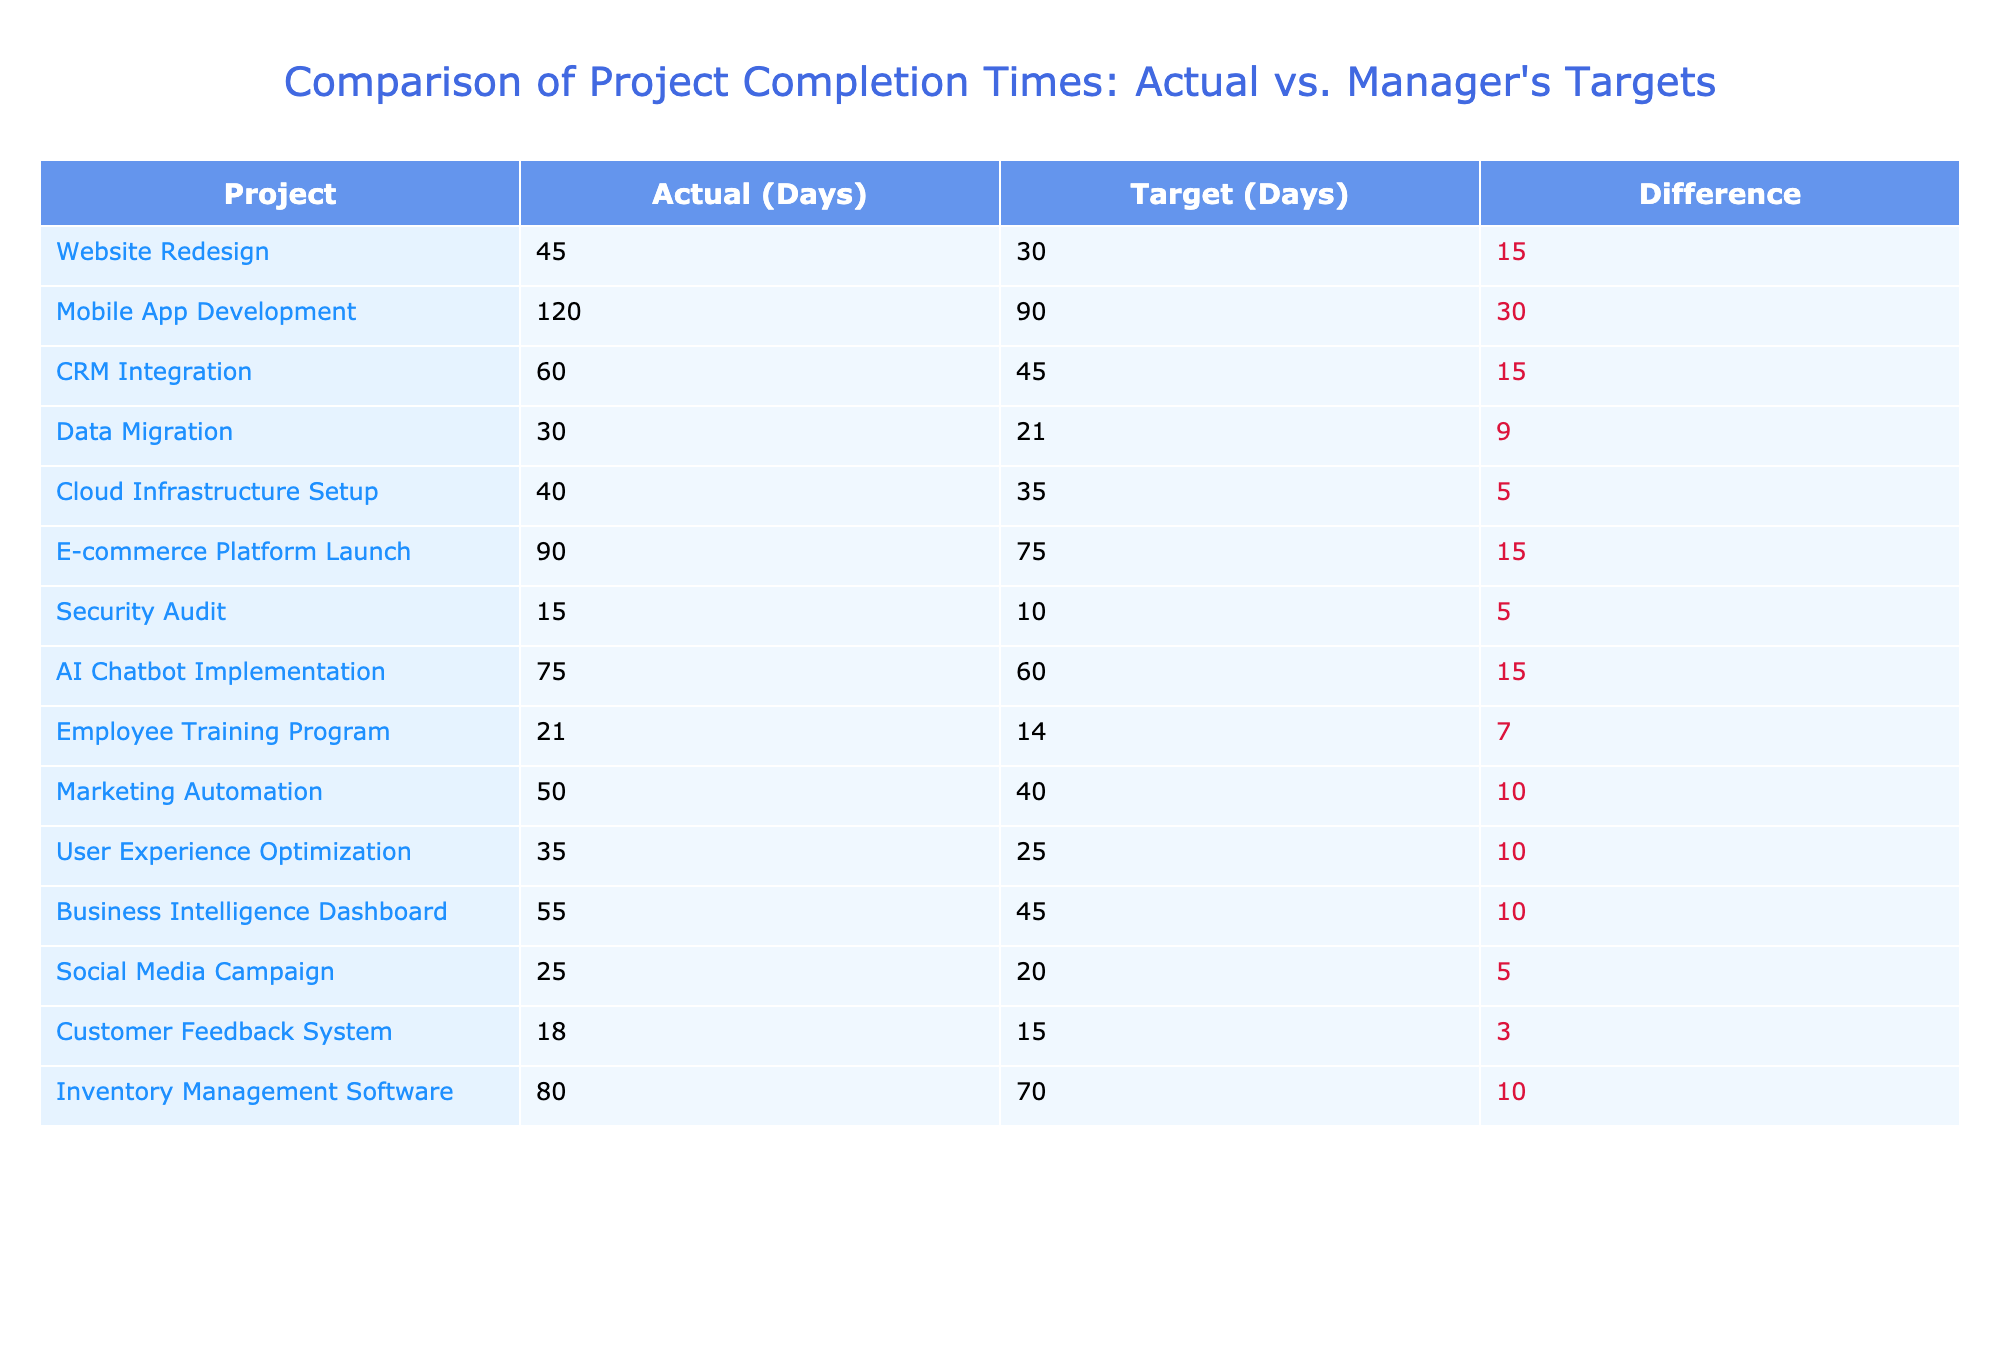What is the actual completion time for the CRM Integration project? The table directly lists the actual completion time for the CRM Integration project as 60 days.
Answer: 60 days Which project had the largest difference between actual completion time and manager's target? By analyzing the "Difference" column, the largest difference is found in the Mobile App Development project, with an actual completion time of 120 days and a target of 90 days, resulting in a difference of 30 days.
Answer: Mobile App Development Is the actual completion time for the Security Audit project greater than its manager's target? The actual completion time for the Security Audit project is 15 days, while the target is 10 days. Since 15 is greater than 10, the statement is true.
Answer: Yes What is the total difference across all projects between actual completion time and manager's targets? To calculate the total difference, sum up the values in the "Difference" column. The differences for each project are: 15, 30, 15, 9, 5, 15, 10, 15, 7, 10, 10, 10, 5, 3, and 10. The total sum is calculated as 15 + 30 + 15 + 9 + 5 + 15 + 10 + 15 + 7 + 10 + 10 + 10 + 5 + 3 + 10 = 10, resulting in a total difference of 121 days.
Answer: 121 days What is the average actual completion time for projects that exceeded their manager's targets? First, we identify the projects exceeding their targets: Website Redesign, Mobile App Development, CRM Integration, E-commerce Platform Launch, AI Chatbot Implementation, and Inventory Management Software. Their actual completion times are: 45, 120, 60, 90, 75, and 80 days, respectively. Summing these gives 45 + 120 + 60 + 90 + 75 + 80 = 470. There are 6 projects, so the average is 470/6 = 78.33 days.
Answer: 78.33 days 